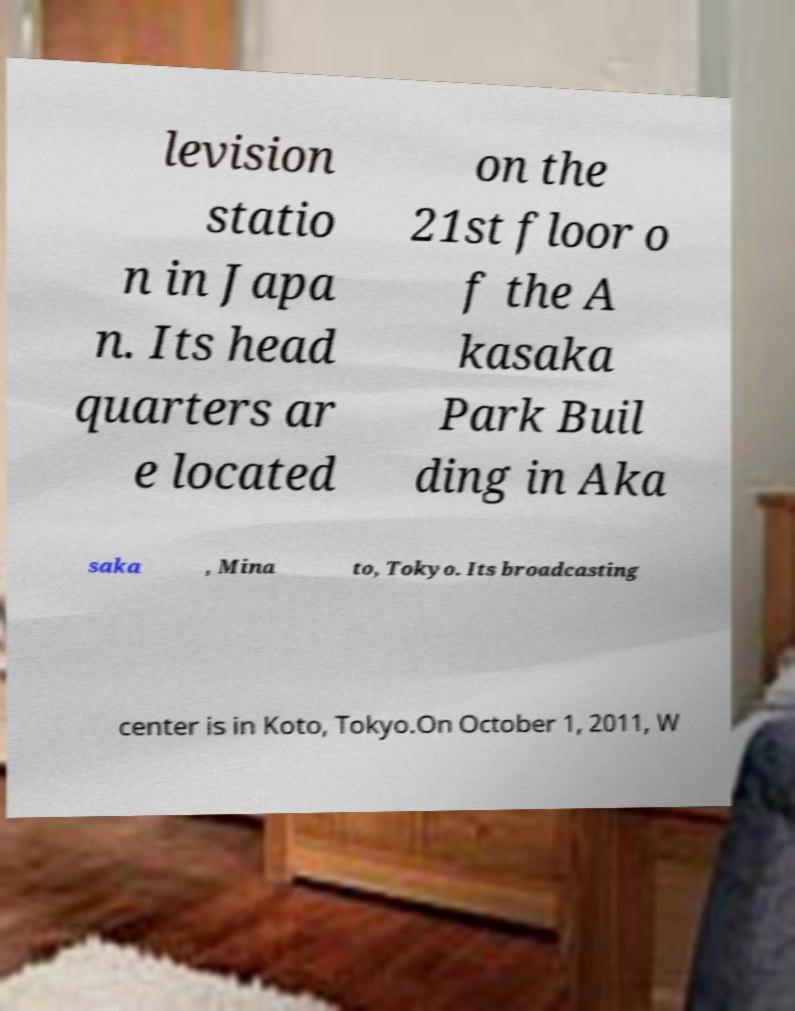Please read and relay the text visible in this image. What does it say? levision statio n in Japa n. Its head quarters ar e located on the 21st floor o f the A kasaka Park Buil ding in Aka saka , Mina to, Tokyo. Its broadcasting center is in Koto, Tokyo.On October 1, 2011, W 